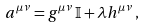<formula> <loc_0><loc_0><loc_500><loc_500>a ^ { \mu \nu } = g ^ { \mu \nu } \, \mathbb { I } + \lambda h ^ { \mu \nu } \, ,</formula> 